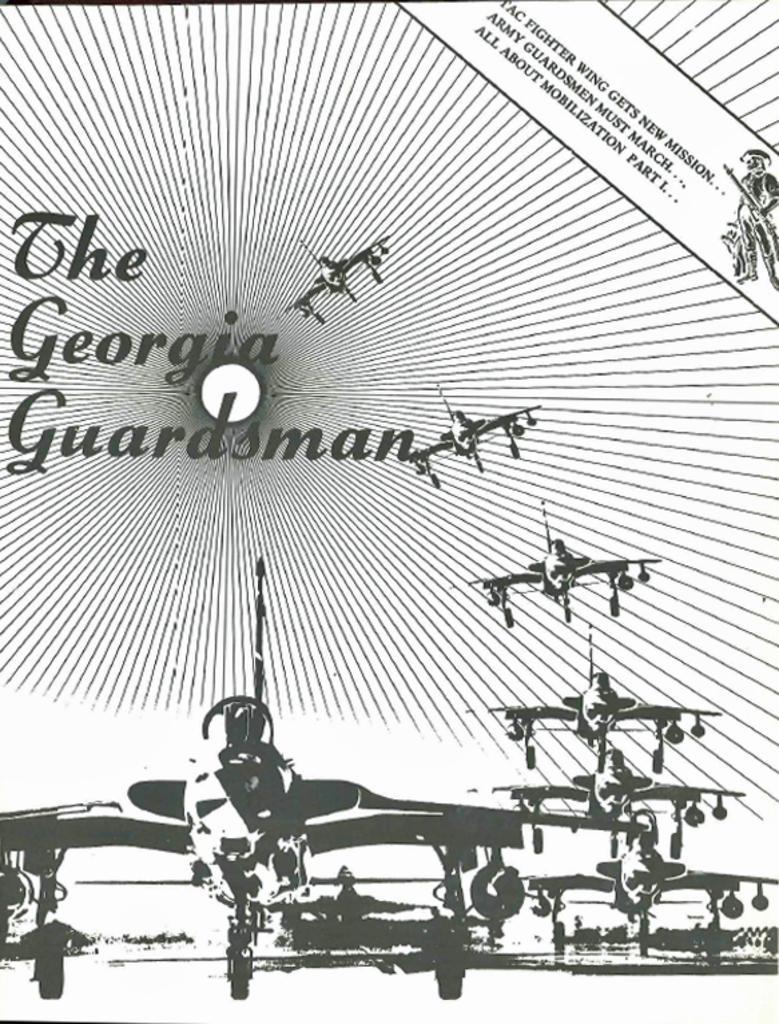Describe this image in one or two sentences. In this image I can see few aircraft's and something is written on it. It is in white and black color. 